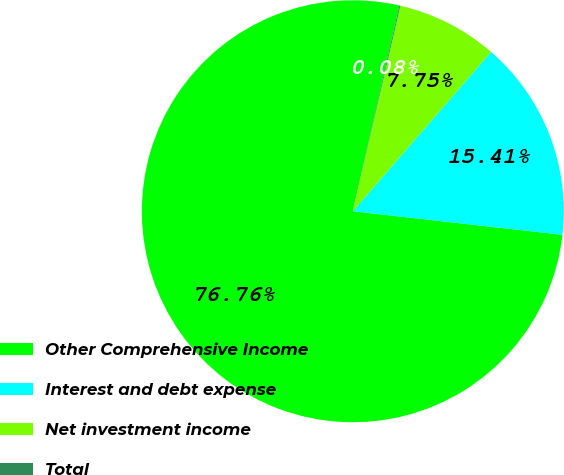Convert chart. <chart><loc_0><loc_0><loc_500><loc_500><pie_chart><fcel>Other Comprehensive Income<fcel>Interest and debt expense<fcel>Net investment income<fcel>Total<nl><fcel>76.76%<fcel>15.41%<fcel>7.75%<fcel>0.08%<nl></chart> 